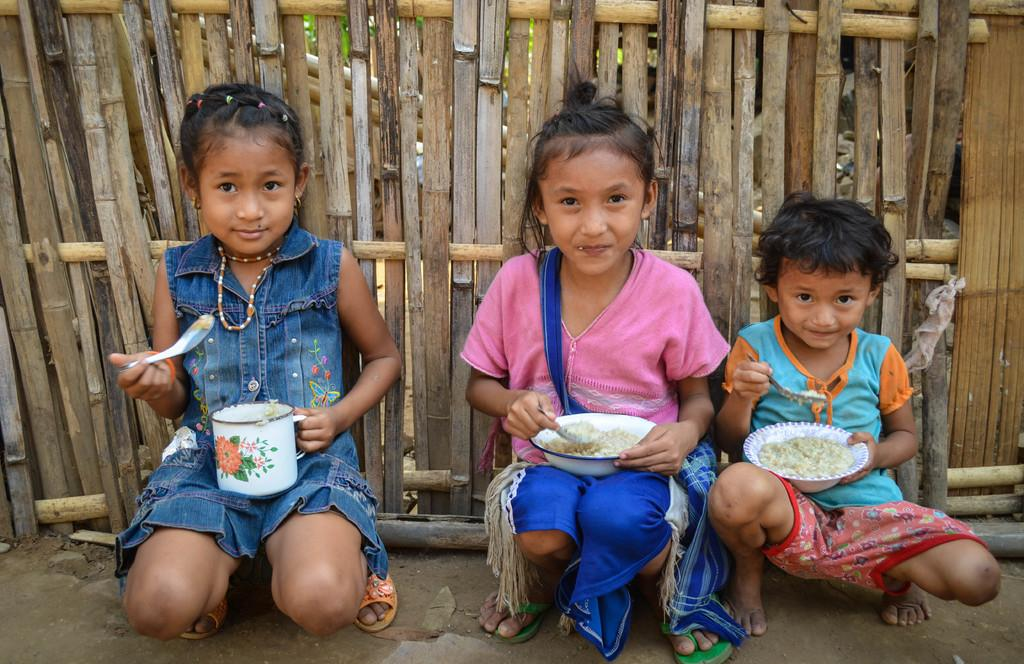How many kids are present in the image? There are three kids in the image. What are the kids doing in the image? The kids are having food on the ground. What is the expression on the kids' faces? The kids are smiling. What can be seen in the background of the image? There is a wooden fence in the background of the image. What day of the week is it in the image? The day of the week cannot be determined from the image. How far away is the lookout point from the kids in the image? There is no lookout point mentioned in the image, so it is impossible to determine the distance. 